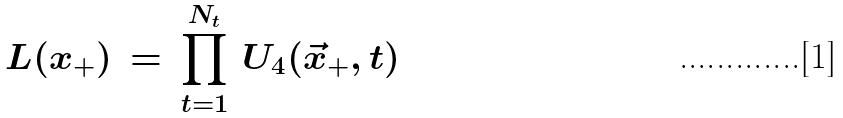<formula> <loc_0><loc_0><loc_500><loc_500>L ( x _ { + } ) \, = \, \prod _ { t = 1 } ^ { N _ { t } } \, U _ { 4 } ( \vec { x } _ { + } , t )</formula> 